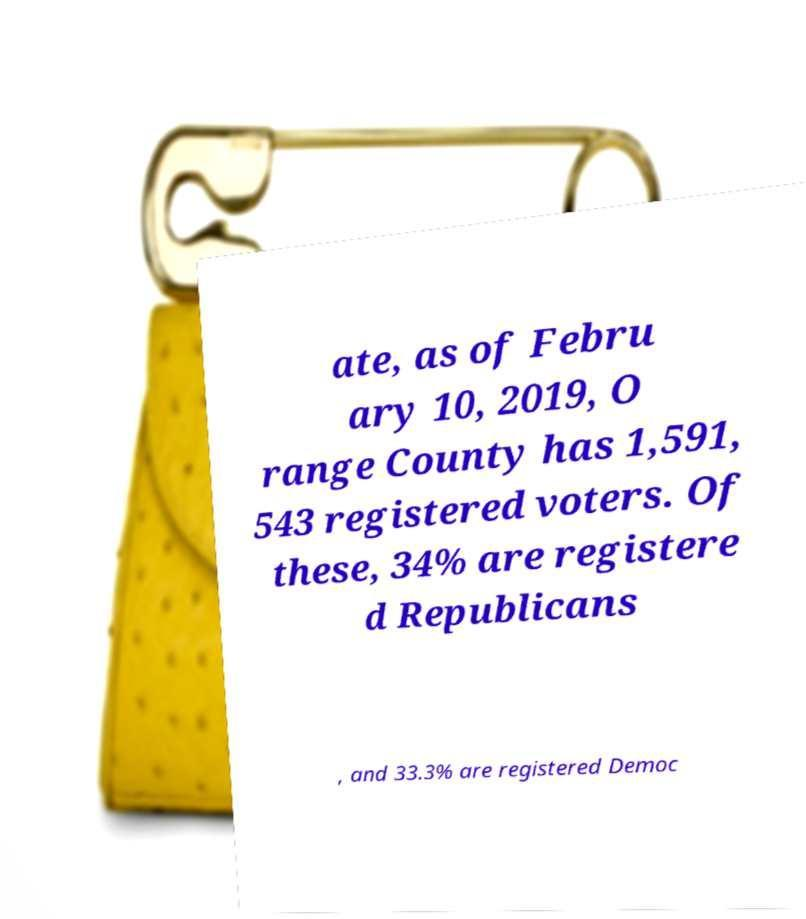Could you extract and type out the text from this image? ate, as of Febru ary 10, 2019, O range County has 1,591, 543 registered voters. Of these, 34% are registere d Republicans , and 33.3% are registered Democ 